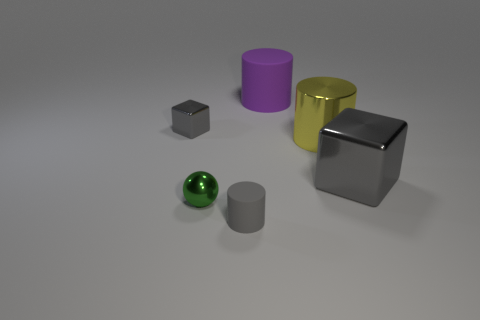Can you describe the atmosphere or mood conveyed by this image? The image has a clean and minimalistic atmosphere, with a neutral background that focuses attention on the objects. The simplicity and the balance of shapes and colors impart a calm and orderly mood, typical of a controlled setting like a product display or a 3D model test render. 